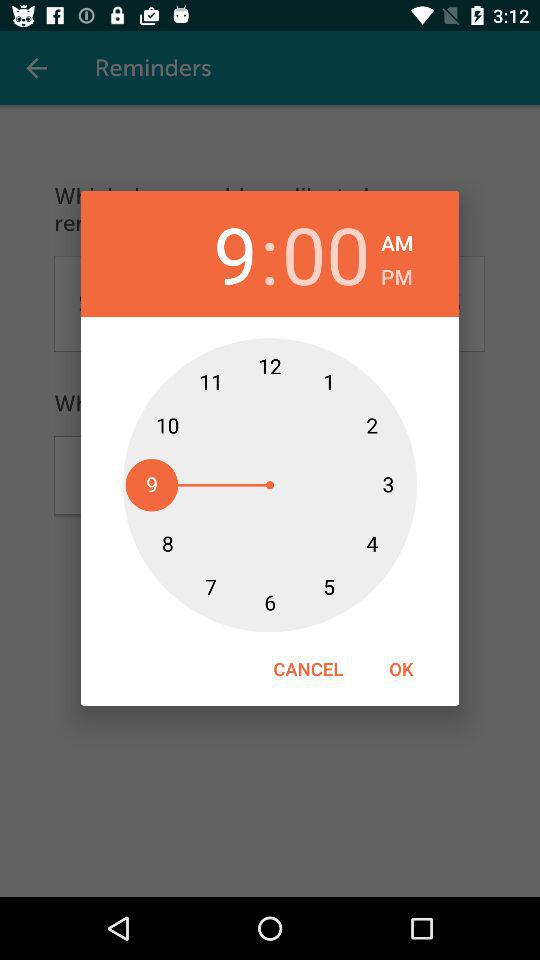What is the shown time? The shown time is 9:00 AM. 